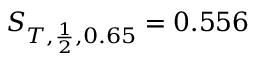Convert formula to latex. <formula><loc_0><loc_0><loc_500><loc_500>S _ { T , \frac { 1 } { 2 } , 0 . 6 5 } = 0 . 5 5 6</formula> 